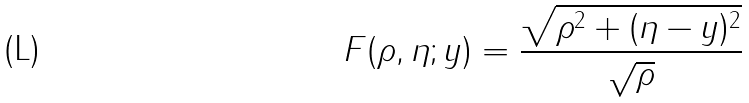Convert formula to latex. <formula><loc_0><loc_0><loc_500><loc_500>F ( \rho , \eta ; y ) = \frac { \sqrt { \rho ^ { 2 } + ( \eta - y ) ^ { 2 } } } { \sqrt { \rho } }</formula> 